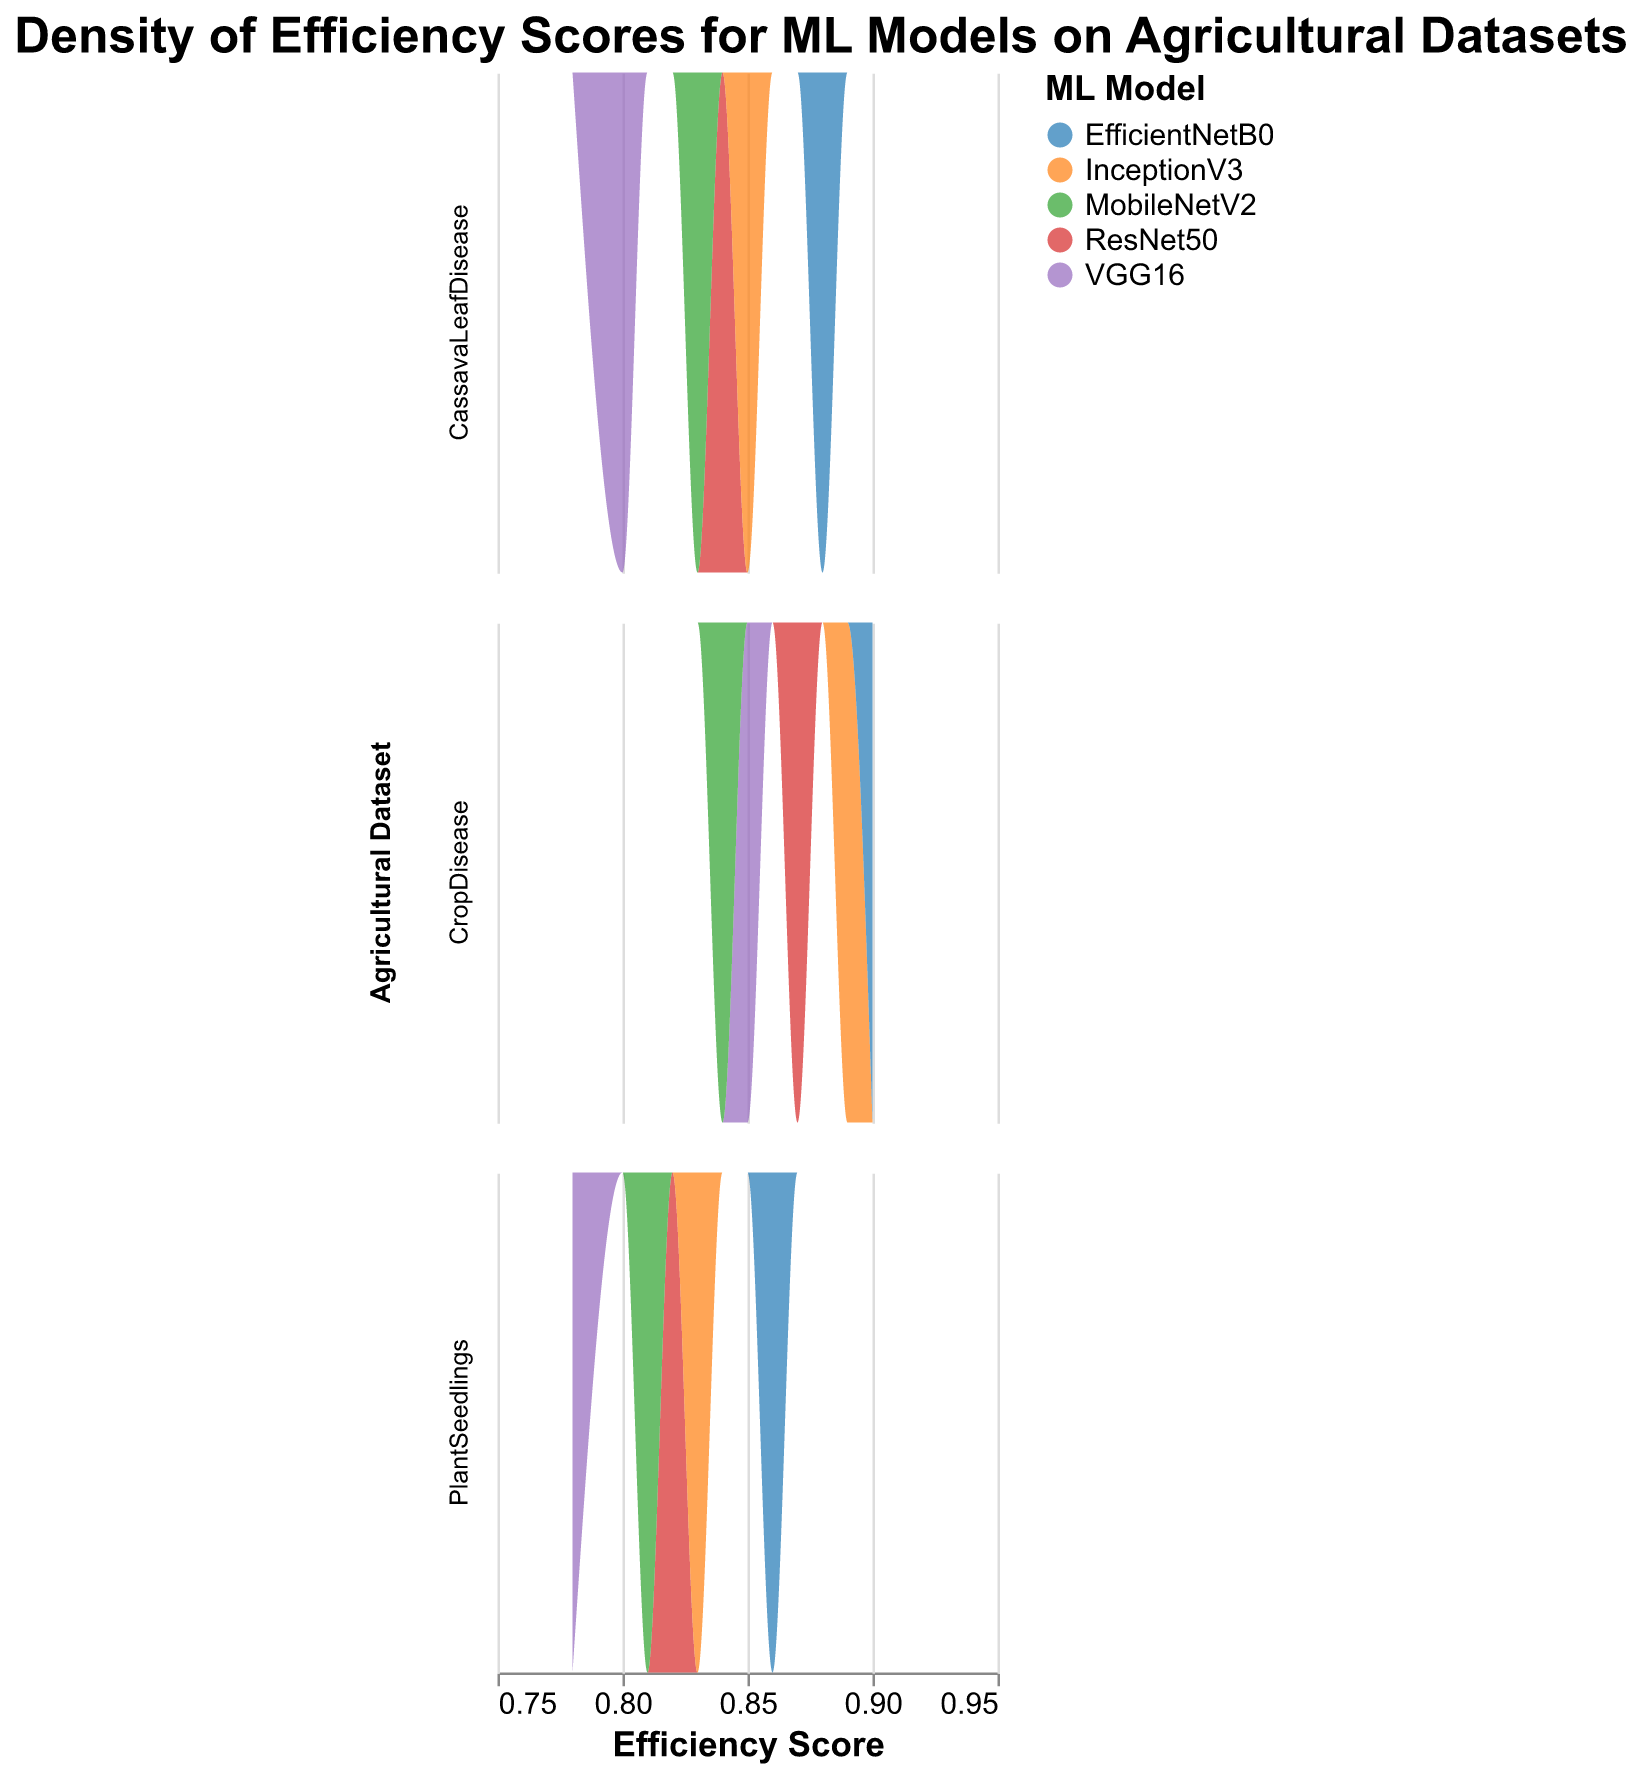What is the title of the figure? The title is often located at the top or center of the figure and provides a brief summary of what the figure represents. In this case, the title is "Density of Efficiency Scores for ML Models on Agricultural Datasets".
Answer: Density of Efficiency Scores for ML Models on Agricultural Datasets What do the x-axis values represent? The x-axis in the figure is labeled "Efficiency Score", indicating that the values represent the efficiency scores of different ML models applied to the agricultural datasets.
Answer: Efficiency Score Which data point has the highest efficiency score? By looking at the plotted density distributions, EfficientNetB0 applied to the CropDisease dataset shows the peak density for the highest efficiency score.
Answer: EfficientNetB0, CropDisease Is there any model that shows consistently high efficiency scores across all datasets? To answer this, we look at the density curves for each dataset and see which model consistently appears towards the higher end of the efficiency score range. EfficientNetB0 shows high efficiency scores across all three datasets.
Answer: EfficientNetB0 What are the datasets represented in the subplots? This is indicated by the facet rows which are titled "Agricultural Dataset". The datasets in the subplots are CropDisease, PlantSeedlings, and CassavaLeafDisease.
Answer: CropDisease, PlantSeedlings, CassavaLeafDisease Which ML model has the least efficiency score on the PlantSeedlings dataset? By analyzing the density plot for the PlantSeedlings dataset subplot, VGG16 shows the lowest efficiency score among the models.
Answer: VGG16 Which dataset shows the highest density of efficiency scores above 0.85? By examining the density plots, we can see that the CropDisease dataset has the highest density of efficiency scores above 0.85, notably with models like EfficientNetB0 and InceptionV3.
Answer: CropDisease Compare the efficiency scores of ResNet50 and MobileNetV2 for the CassavaLeafDisease dataset and find which one is higher. By examining the density plot for the CassavaLeafDisease dataset, it's clear that ResNet50 and MobileNetV2 have similar peaks, but MobileNetV2 has a slightly higher efficiency score density.
Answer: MobileNetV2 Which model has a more pronounced peak in the CropDisease dataset? To determine this, we analyze the density plots for the CropDisease dataset. EfficientNetB0 shows the most pronounced peak in this dataset.
Answer: EfficientNetB0 